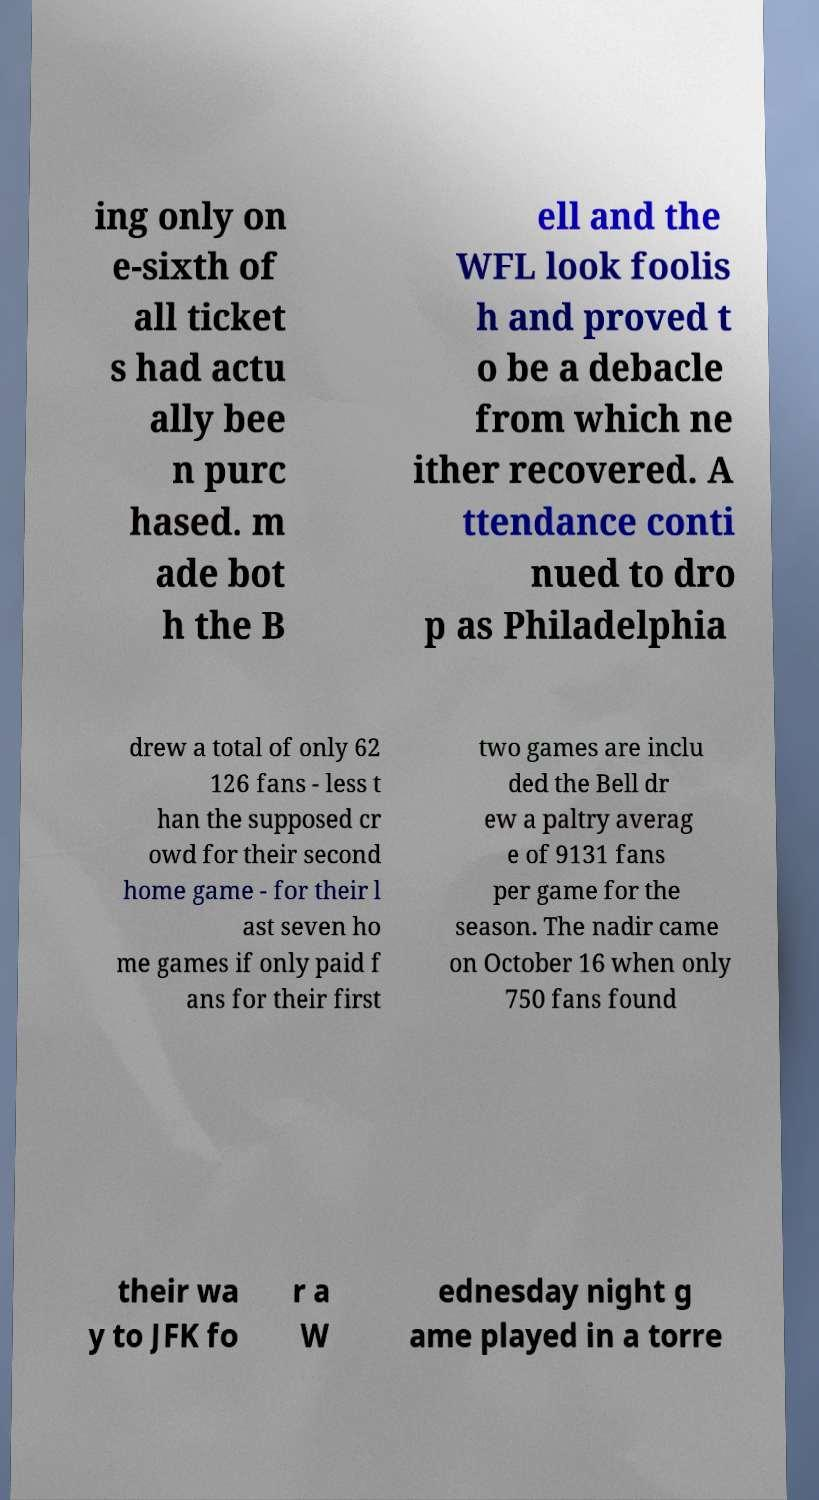Could you assist in decoding the text presented in this image and type it out clearly? ing only on e-sixth of all ticket s had actu ally bee n purc hased. m ade bot h the B ell and the WFL look foolis h and proved t o be a debacle from which ne ither recovered. A ttendance conti nued to dro p as Philadelphia drew a total of only 62 126 fans - less t han the supposed cr owd for their second home game - for their l ast seven ho me games if only paid f ans for their first two games are inclu ded the Bell dr ew a paltry averag e of 9131 fans per game for the season. The nadir came on October 16 when only 750 fans found their wa y to JFK fo r a W ednesday night g ame played in a torre 